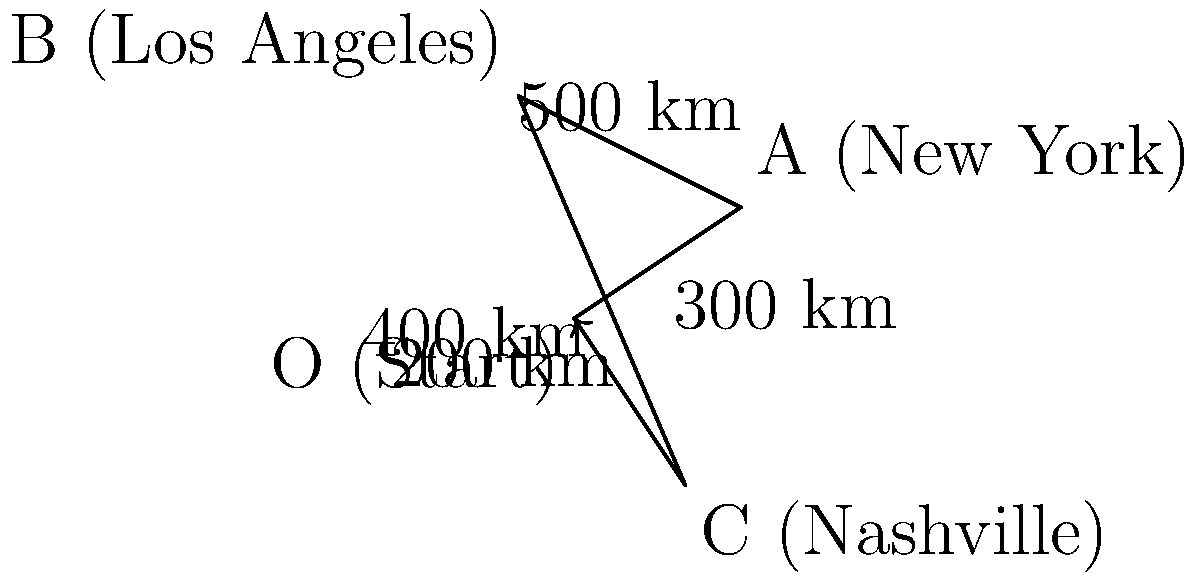Aubrey Riley is going on a concert tour! She starts in her hometown, then travels to New York, Los Angeles, and Nashville before returning home. If the distances between each city are shown in the diagram (in kilometers), what is the total distance Aubrey travels during her tour? Let's break this down step-by-step:

1) First, we need to identify each leg of the journey:
   - Hometown to New York: 300 km
   - New York to Los Angeles: 500 km
   - Los Angeles to Nashville: 400 km
   - Nashville back to Hometown: 200 km

2) To find the total distance, we simply need to add up all these distances:

   $$\text{Total Distance} = 300 + 500 + 400 + 200$$

3) Now let's calculate:

   $$\text{Total Distance} = 1400 \text{ km}$$

Therefore, Aubrey Riley travels a total of 1400 kilometers during her concert tour.
Answer: 1400 km 